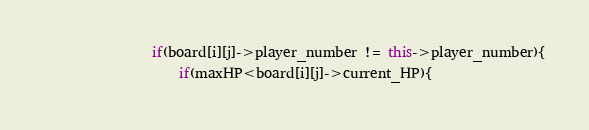Convert code to text. <code><loc_0><loc_0><loc_500><loc_500><_C++_>				if(board[i][j]->player_number != this->player_number){
					if(maxHP<board[i][j]->current_HP){</code> 